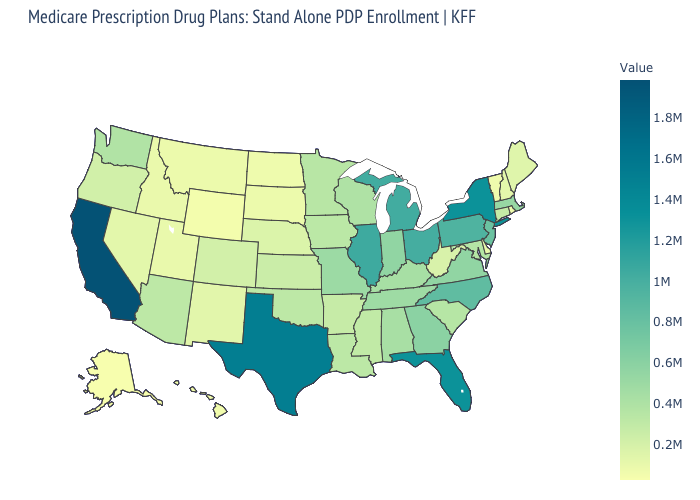Does Pennsylvania have the highest value in the USA?
Give a very brief answer. No. Which states have the highest value in the USA?
Short answer required. California. Which states have the lowest value in the MidWest?
Answer briefly. North Dakota. 